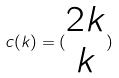Convert formula to latex. <formula><loc_0><loc_0><loc_500><loc_500>c ( k ) = ( \begin{matrix} 2 k \\ k \end{matrix} )</formula> 